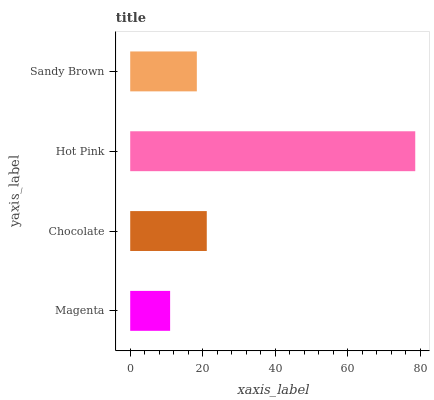Is Magenta the minimum?
Answer yes or no. Yes. Is Hot Pink the maximum?
Answer yes or no. Yes. Is Chocolate the minimum?
Answer yes or no. No. Is Chocolate the maximum?
Answer yes or no. No. Is Chocolate greater than Magenta?
Answer yes or no. Yes. Is Magenta less than Chocolate?
Answer yes or no. Yes. Is Magenta greater than Chocolate?
Answer yes or no. No. Is Chocolate less than Magenta?
Answer yes or no. No. Is Chocolate the high median?
Answer yes or no. Yes. Is Sandy Brown the low median?
Answer yes or no. Yes. Is Hot Pink the high median?
Answer yes or no. No. Is Chocolate the low median?
Answer yes or no. No. 